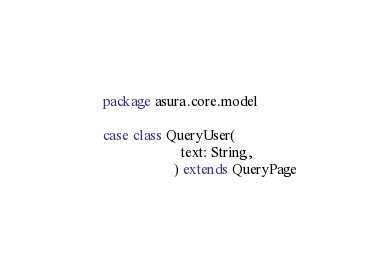Convert code to text. <code><loc_0><loc_0><loc_500><loc_500><_Scala_>package asura.core.model

case class QueryUser(
                      text: String,
                    ) extends QueryPage
</code> 